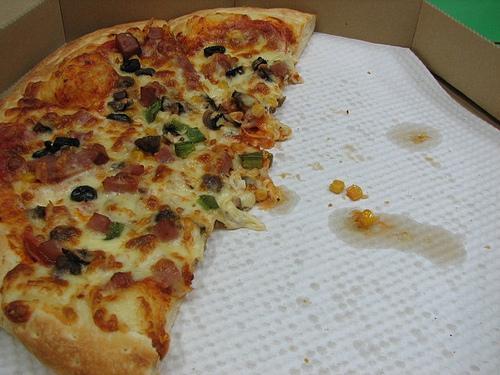How many slices are there?
Give a very brief answer. 4. 